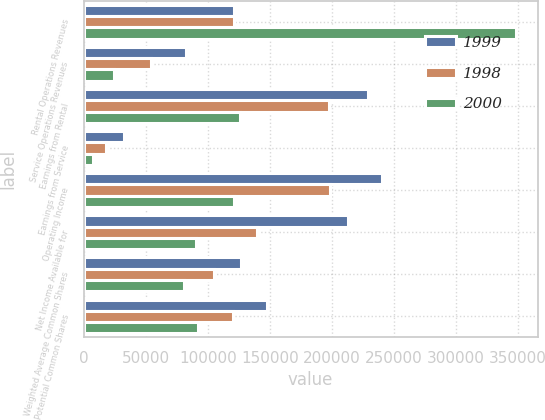Convert chart. <chart><loc_0><loc_0><loc_500><loc_500><stacked_bar_chart><ecel><fcel>Rental Operations Revenues<fcel>Service Operations Revenues<fcel>Earnings from Rental<fcel>Earnings from Service<fcel>Operating Income<fcel>Net Income Available for<fcel>Weighted Average Common Shares<fcel>Potential Common Shares<nl><fcel>1999<fcel>121050<fcel>82799<fcel>228987<fcel>32760<fcel>240603<fcel>212958<fcel>126836<fcel>147441<nl><fcel>1998<fcel>121050<fcel>54031<fcel>197474<fcel>17872<fcel>198790<fcel>139636<fcel>104884<fcel>120511<nl><fcel>2000<fcel>348625<fcel>24716<fcel>125967<fcel>7195<fcel>121589<fcel>90871<fcel>80704<fcel>92468<nl></chart> 